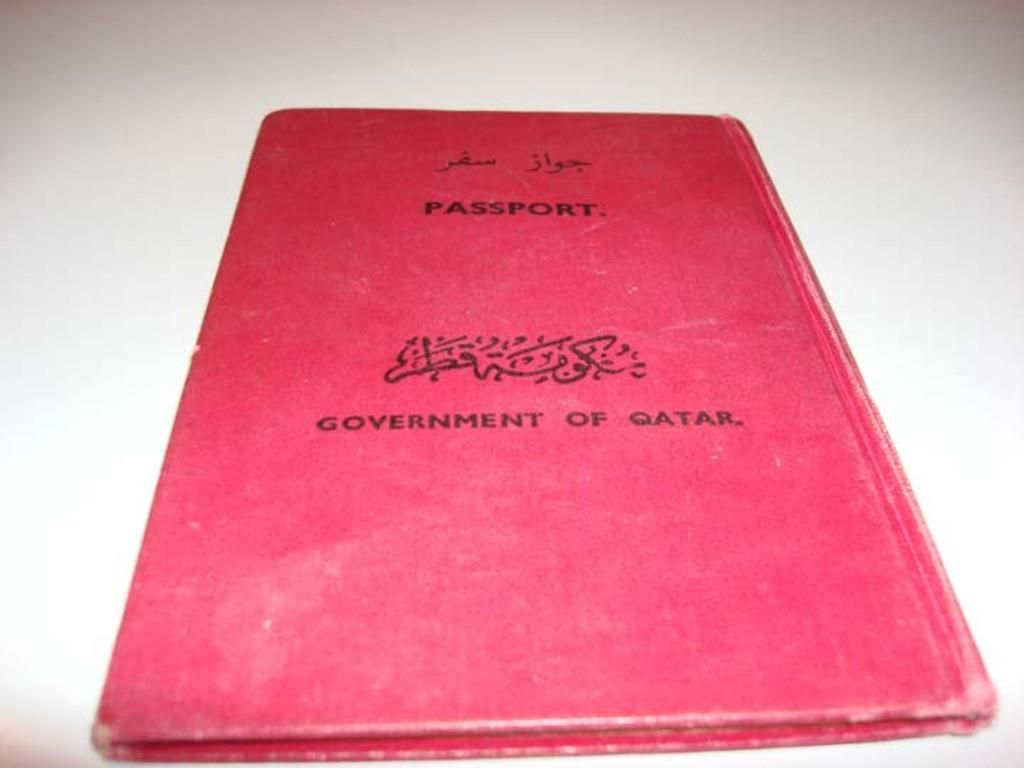<image>
Render a clear and concise summary of the photo. A worn red passport from the government of qatar. 